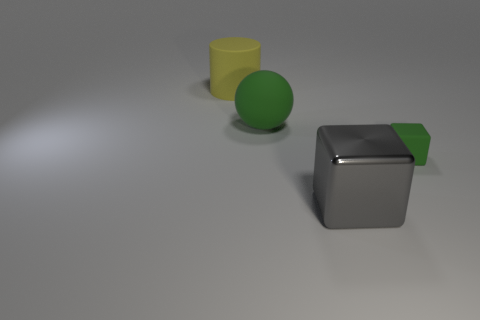Add 4 balls. How many objects exist? 8 Subtract all gray blocks. How many blocks are left? 1 Subtract 1 cubes. How many cubes are left? 1 Subtract all gray blocks. Subtract all green spheres. How many blocks are left? 1 Subtract all tiny purple metallic cylinders. Subtract all gray objects. How many objects are left? 3 Add 1 big metallic things. How many big metallic things are left? 2 Add 4 large balls. How many large balls exist? 5 Subtract 0 red cylinders. How many objects are left? 4 Subtract all cylinders. How many objects are left? 3 